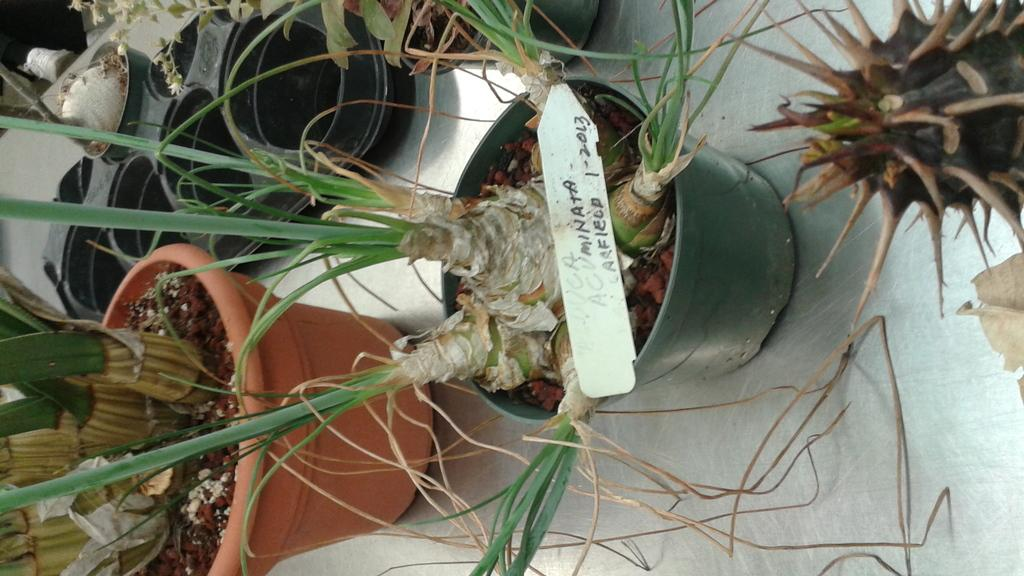What type of plants are on the platform in the image? There are house plants on a platform in the image. What can be seen near the plants on the platform? There is a name board in the image. What else is visible in the image besides the plants and name board? There are objects visible in the background of the image. Are there any sheep visible in the image? No, there are no sheep present in the image. What type of animal can be seen interacting with the house plants in the image? There are no animals visible in the image; it only features house plants and a name board. 